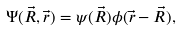<formula> <loc_0><loc_0><loc_500><loc_500>\Psi ( \vec { R } , \vec { r } ) = \psi ( \vec { R } ) \phi ( \vec { r } - \vec { R } ) ,</formula> 